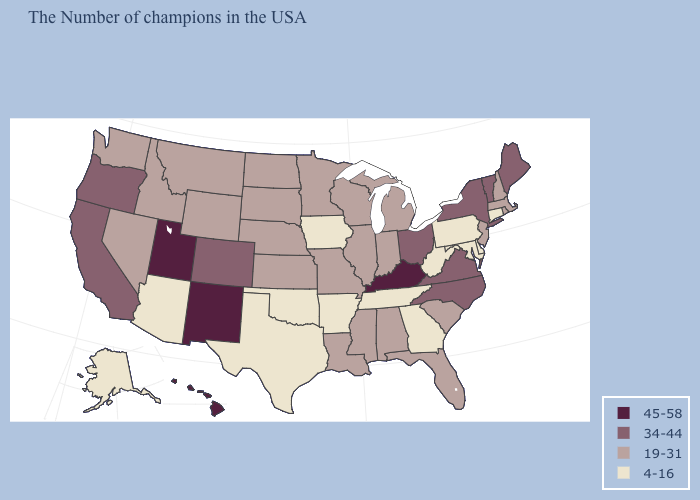What is the highest value in the South ?
Quick response, please. 45-58. Does the first symbol in the legend represent the smallest category?
Give a very brief answer. No. Which states have the lowest value in the MidWest?
Write a very short answer. Iowa. Name the states that have a value in the range 34-44?
Concise answer only. Maine, Vermont, New York, Virginia, North Carolina, Ohio, Colorado, California, Oregon. Among the states that border New Jersey , does Delaware have the highest value?
Quick response, please. No. Name the states that have a value in the range 45-58?
Concise answer only. Kentucky, New Mexico, Utah, Hawaii. Among the states that border Indiana , which have the lowest value?
Short answer required. Michigan, Illinois. Does New York have the same value as Colorado?
Short answer required. Yes. What is the highest value in the Northeast ?
Give a very brief answer. 34-44. Name the states that have a value in the range 34-44?
Quick response, please. Maine, Vermont, New York, Virginia, North Carolina, Ohio, Colorado, California, Oregon. What is the value of Georgia?
Concise answer only. 4-16. What is the value of Wisconsin?
Quick response, please. 19-31. Name the states that have a value in the range 34-44?
Short answer required. Maine, Vermont, New York, Virginia, North Carolina, Ohio, Colorado, California, Oregon. Does Maine have the lowest value in the Northeast?
Short answer required. No. Among the states that border Illinois , which have the highest value?
Keep it brief. Kentucky. 